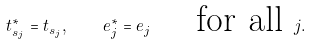<formula> <loc_0><loc_0><loc_500><loc_500>t _ { s _ { j } } ^ { * } = t _ { s _ { j } } , \quad e _ { j } ^ { * } = e _ { j } \quad \text { for all } j .</formula> 